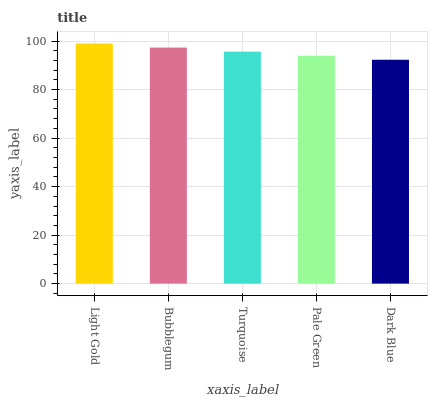Is Dark Blue the minimum?
Answer yes or no. Yes. Is Light Gold the maximum?
Answer yes or no. Yes. Is Bubblegum the minimum?
Answer yes or no. No. Is Bubblegum the maximum?
Answer yes or no. No. Is Light Gold greater than Bubblegum?
Answer yes or no. Yes. Is Bubblegum less than Light Gold?
Answer yes or no. Yes. Is Bubblegum greater than Light Gold?
Answer yes or no. No. Is Light Gold less than Bubblegum?
Answer yes or no. No. Is Turquoise the high median?
Answer yes or no. Yes. Is Turquoise the low median?
Answer yes or no. Yes. Is Light Gold the high median?
Answer yes or no. No. Is Pale Green the low median?
Answer yes or no. No. 